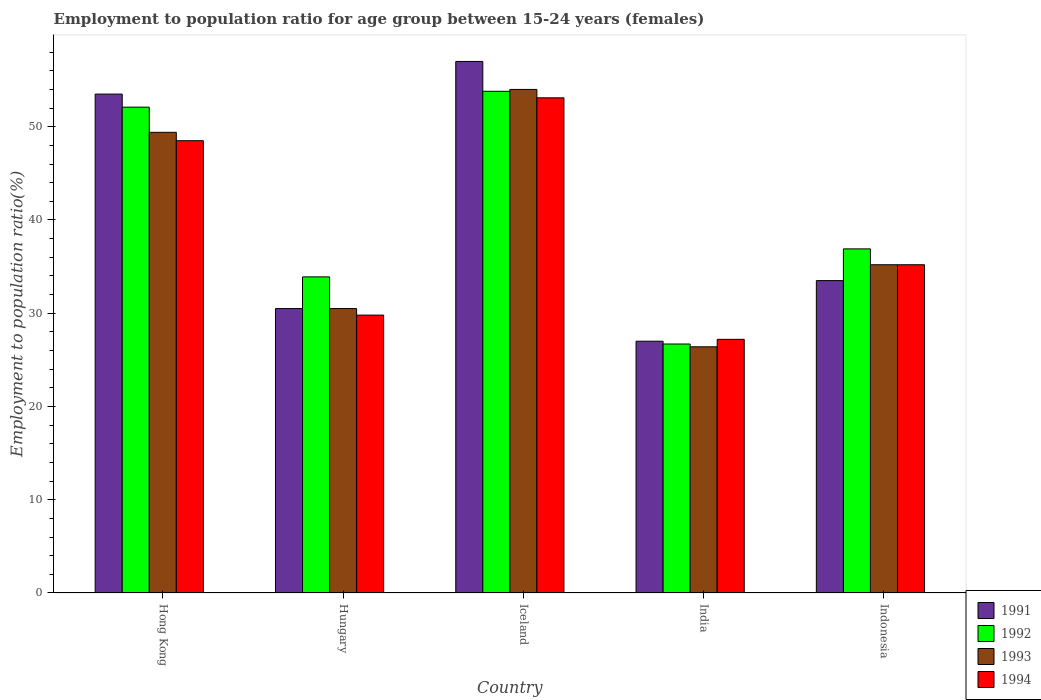Are the number of bars per tick equal to the number of legend labels?
Your answer should be very brief. Yes. How many bars are there on the 3rd tick from the left?
Offer a terse response. 4. How many bars are there on the 1st tick from the right?
Offer a terse response. 4. What is the label of the 2nd group of bars from the left?
Make the answer very short. Hungary. In how many cases, is the number of bars for a given country not equal to the number of legend labels?
Give a very brief answer. 0. What is the employment to population ratio in 1994 in Hong Kong?
Give a very brief answer. 48.5. Across all countries, what is the maximum employment to population ratio in 1992?
Ensure brevity in your answer.  53.8. Across all countries, what is the minimum employment to population ratio in 1994?
Your answer should be very brief. 27.2. What is the total employment to population ratio in 1992 in the graph?
Offer a very short reply. 203.4. What is the difference between the employment to population ratio in 1992 in Hong Kong and that in Hungary?
Provide a succinct answer. 18.2. What is the difference between the employment to population ratio in 1992 in Indonesia and the employment to population ratio in 1991 in Iceland?
Make the answer very short. -20.1. What is the average employment to population ratio in 1992 per country?
Ensure brevity in your answer.  40.68. What is the difference between the employment to population ratio of/in 1994 and employment to population ratio of/in 1993 in India?
Your response must be concise. 0.8. In how many countries, is the employment to population ratio in 1993 greater than 4 %?
Provide a short and direct response. 5. What is the ratio of the employment to population ratio in 1993 in Hong Kong to that in Iceland?
Your answer should be compact. 0.91. Is the difference between the employment to population ratio in 1994 in Iceland and Indonesia greater than the difference between the employment to population ratio in 1993 in Iceland and Indonesia?
Your answer should be very brief. No. What is the difference between the highest and the second highest employment to population ratio in 1994?
Your answer should be compact. 13.3. What is the difference between the highest and the lowest employment to population ratio in 1992?
Ensure brevity in your answer.  27.1. In how many countries, is the employment to population ratio in 1992 greater than the average employment to population ratio in 1992 taken over all countries?
Your answer should be very brief. 2. What does the 2nd bar from the right in India represents?
Provide a succinct answer. 1993. How many bars are there?
Give a very brief answer. 20. What is the difference between two consecutive major ticks on the Y-axis?
Your answer should be very brief. 10. Are the values on the major ticks of Y-axis written in scientific E-notation?
Give a very brief answer. No. Does the graph contain grids?
Keep it short and to the point. No. Where does the legend appear in the graph?
Keep it short and to the point. Bottom right. What is the title of the graph?
Offer a terse response. Employment to population ratio for age group between 15-24 years (females). What is the label or title of the X-axis?
Your answer should be very brief. Country. What is the Employment to population ratio(%) in 1991 in Hong Kong?
Offer a very short reply. 53.5. What is the Employment to population ratio(%) of 1992 in Hong Kong?
Your answer should be compact. 52.1. What is the Employment to population ratio(%) in 1993 in Hong Kong?
Your answer should be very brief. 49.4. What is the Employment to population ratio(%) in 1994 in Hong Kong?
Your response must be concise. 48.5. What is the Employment to population ratio(%) in 1991 in Hungary?
Ensure brevity in your answer.  30.5. What is the Employment to population ratio(%) of 1992 in Hungary?
Provide a short and direct response. 33.9. What is the Employment to population ratio(%) in 1993 in Hungary?
Offer a very short reply. 30.5. What is the Employment to population ratio(%) of 1994 in Hungary?
Make the answer very short. 29.8. What is the Employment to population ratio(%) in 1991 in Iceland?
Give a very brief answer. 57. What is the Employment to population ratio(%) in 1992 in Iceland?
Provide a succinct answer. 53.8. What is the Employment to population ratio(%) in 1994 in Iceland?
Provide a short and direct response. 53.1. What is the Employment to population ratio(%) of 1991 in India?
Give a very brief answer. 27. What is the Employment to population ratio(%) in 1992 in India?
Keep it short and to the point. 26.7. What is the Employment to population ratio(%) of 1993 in India?
Make the answer very short. 26.4. What is the Employment to population ratio(%) in 1994 in India?
Offer a very short reply. 27.2. What is the Employment to population ratio(%) of 1991 in Indonesia?
Offer a very short reply. 33.5. What is the Employment to population ratio(%) of 1992 in Indonesia?
Keep it short and to the point. 36.9. What is the Employment to population ratio(%) in 1993 in Indonesia?
Your answer should be very brief. 35.2. What is the Employment to population ratio(%) of 1994 in Indonesia?
Make the answer very short. 35.2. Across all countries, what is the maximum Employment to population ratio(%) of 1991?
Make the answer very short. 57. Across all countries, what is the maximum Employment to population ratio(%) of 1992?
Offer a very short reply. 53.8. Across all countries, what is the maximum Employment to population ratio(%) of 1994?
Offer a very short reply. 53.1. Across all countries, what is the minimum Employment to population ratio(%) of 1991?
Ensure brevity in your answer.  27. Across all countries, what is the minimum Employment to population ratio(%) of 1992?
Give a very brief answer. 26.7. Across all countries, what is the minimum Employment to population ratio(%) of 1993?
Provide a succinct answer. 26.4. Across all countries, what is the minimum Employment to population ratio(%) in 1994?
Give a very brief answer. 27.2. What is the total Employment to population ratio(%) of 1991 in the graph?
Your answer should be very brief. 201.5. What is the total Employment to population ratio(%) in 1992 in the graph?
Offer a very short reply. 203.4. What is the total Employment to population ratio(%) in 1993 in the graph?
Your response must be concise. 195.5. What is the total Employment to population ratio(%) of 1994 in the graph?
Your answer should be compact. 193.8. What is the difference between the Employment to population ratio(%) in 1991 in Hong Kong and that in Hungary?
Your response must be concise. 23. What is the difference between the Employment to population ratio(%) of 1992 in Hong Kong and that in Hungary?
Your answer should be compact. 18.2. What is the difference between the Employment to population ratio(%) of 1993 in Hong Kong and that in Hungary?
Offer a terse response. 18.9. What is the difference between the Employment to population ratio(%) in 1992 in Hong Kong and that in India?
Give a very brief answer. 25.4. What is the difference between the Employment to population ratio(%) of 1994 in Hong Kong and that in India?
Your response must be concise. 21.3. What is the difference between the Employment to population ratio(%) of 1991 in Hong Kong and that in Indonesia?
Keep it short and to the point. 20. What is the difference between the Employment to population ratio(%) in 1993 in Hong Kong and that in Indonesia?
Provide a short and direct response. 14.2. What is the difference between the Employment to population ratio(%) of 1994 in Hong Kong and that in Indonesia?
Provide a short and direct response. 13.3. What is the difference between the Employment to population ratio(%) of 1991 in Hungary and that in Iceland?
Provide a short and direct response. -26.5. What is the difference between the Employment to population ratio(%) in 1992 in Hungary and that in Iceland?
Offer a very short reply. -19.9. What is the difference between the Employment to population ratio(%) of 1993 in Hungary and that in Iceland?
Your answer should be compact. -23.5. What is the difference between the Employment to population ratio(%) in 1994 in Hungary and that in Iceland?
Provide a short and direct response. -23.3. What is the difference between the Employment to population ratio(%) of 1992 in Hungary and that in India?
Make the answer very short. 7.2. What is the difference between the Employment to population ratio(%) in 1992 in Iceland and that in India?
Provide a short and direct response. 27.1. What is the difference between the Employment to population ratio(%) in 1993 in Iceland and that in India?
Keep it short and to the point. 27.6. What is the difference between the Employment to population ratio(%) in 1994 in Iceland and that in India?
Give a very brief answer. 25.9. What is the difference between the Employment to population ratio(%) in 1991 in Iceland and that in Indonesia?
Offer a very short reply. 23.5. What is the difference between the Employment to population ratio(%) of 1993 in Iceland and that in Indonesia?
Offer a very short reply. 18.8. What is the difference between the Employment to population ratio(%) in 1994 in Iceland and that in Indonesia?
Offer a terse response. 17.9. What is the difference between the Employment to population ratio(%) in 1991 in India and that in Indonesia?
Ensure brevity in your answer.  -6.5. What is the difference between the Employment to population ratio(%) of 1992 in India and that in Indonesia?
Offer a terse response. -10.2. What is the difference between the Employment to population ratio(%) of 1994 in India and that in Indonesia?
Keep it short and to the point. -8. What is the difference between the Employment to population ratio(%) of 1991 in Hong Kong and the Employment to population ratio(%) of 1992 in Hungary?
Make the answer very short. 19.6. What is the difference between the Employment to population ratio(%) of 1991 in Hong Kong and the Employment to population ratio(%) of 1993 in Hungary?
Provide a short and direct response. 23. What is the difference between the Employment to population ratio(%) in 1991 in Hong Kong and the Employment to population ratio(%) in 1994 in Hungary?
Your answer should be very brief. 23.7. What is the difference between the Employment to population ratio(%) of 1992 in Hong Kong and the Employment to population ratio(%) of 1993 in Hungary?
Offer a very short reply. 21.6. What is the difference between the Employment to population ratio(%) of 1992 in Hong Kong and the Employment to population ratio(%) of 1994 in Hungary?
Your response must be concise. 22.3. What is the difference between the Employment to population ratio(%) in 1993 in Hong Kong and the Employment to population ratio(%) in 1994 in Hungary?
Make the answer very short. 19.6. What is the difference between the Employment to population ratio(%) of 1991 in Hong Kong and the Employment to population ratio(%) of 1992 in Iceland?
Offer a terse response. -0.3. What is the difference between the Employment to population ratio(%) in 1991 in Hong Kong and the Employment to population ratio(%) in 1993 in Iceland?
Give a very brief answer. -0.5. What is the difference between the Employment to population ratio(%) of 1992 in Hong Kong and the Employment to population ratio(%) of 1994 in Iceland?
Offer a terse response. -1. What is the difference between the Employment to population ratio(%) of 1991 in Hong Kong and the Employment to population ratio(%) of 1992 in India?
Offer a terse response. 26.8. What is the difference between the Employment to population ratio(%) in 1991 in Hong Kong and the Employment to population ratio(%) in 1993 in India?
Offer a very short reply. 27.1. What is the difference between the Employment to population ratio(%) of 1991 in Hong Kong and the Employment to population ratio(%) of 1994 in India?
Provide a short and direct response. 26.3. What is the difference between the Employment to population ratio(%) in 1992 in Hong Kong and the Employment to population ratio(%) in 1993 in India?
Keep it short and to the point. 25.7. What is the difference between the Employment to population ratio(%) in 1992 in Hong Kong and the Employment to population ratio(%) in 1994 in India?
Provide a succinct answer. 24.9. What is the difference between the Employment to population ratio(%) of 1991 in Hong Kong and the Employment to population ratio(%) of 1994 in Indonesia?
Your response must be concise. 18.3. What is the difference between the Employment to population ratio(%) of 1991 in Hungary and the Employment to population ratio(%) of 1992 in Iceland?
Offer a terse response. -23.3. What is the difference between the Employment to population ratio(%) of 1991 in Hungary and the Employment to population ratio(%) of 1993 in Iceland?
Provide a succinct answer. -23.5. What is the difference between the Employment to population ratio(%) in 1991 in Hungary and the Employment to population ratio(%) in 1994 in Iceland?
Your answer should be very brief. -22.6. What is the difference between the Employment to population ratio(%) of 1992 in Hungary and the Employment to population ratio(%) of 1993 in Iceland?
Make the answer very short. -20.1. What is the difference between the Employment to population ratio(%) in 1992 in Hungary and the Employment to population ratio(%) in 1994 in Iceland?
Provide a succinct answer. -19.2. What is the difference between the Employment to population ratio(%) of 1993 in Hungary and the Employment to population ratio(%) of 1994 in Iceland?
Your answer should be very brief. -22.6. What is the difference between the Employment to population ratio(%) of 1991 in Hungary and the Employment to population ratio(%) of 1992 in India?
Make the answer very short. 3.8. What is the difference between the Employment to population ratio(%) in 1992 in Hungary and the Employment to population ratio(%) in 1994 in India?
Give a very brief answer. 6.7. What is the difference between the Employment to population ratio(%) in 1992 in Hungary and the Employment to population ratio(%) in 1994 in Indonesia?
Make the answer very short. -1.3. What is the difference between the Employment to population ratio(%) in 1991 in Iceland and the Employment to population ratio(%) in 1992 in India?
Provide a short and direct response. 30.3. What is the difference between the Employment to population ratio(%) of 1991 in Iceland and the Employment to population ratio(%) of 1993 in India?
Your answer should be compact. 30.6. What is the difference between the Employment to population ratio(%) in 1991 in Iceland and the Employment to population ratio(%) in 1994 in India?
Provide a short and direct response. 29.8. What is the difference between the Employment to population ratio(%) of 1992 in Iceland and the Employment to population ratio(%) of 1993 in India?
Provide a succinct answer. 27.4. What is the difference between the Employment to population ratio(%) in 1992 in Iceland and the Employment to population ratio(%) in 1994 in India?
Ensure brevity in your answer.  26.6. What is the difference between the Employment to population ratio(%) of 1993 in Iceland and the Employment to population ratio(%) of 1994 in India?
Offer a terse response. 26.8. What is the difference between the Employment to population ratio(%) in 1991 in Iceland and the Employment to population ratio(%) in 1992 in Indonesia?
Offer a very short reply. 20.1. What is the difference between the Employment to population ratio(%) in 1991 in Iceland and the Employment to population ratio(%) in 1993 in Indonesia?
Provide a succinct answer. 21.8. What is the difference between the Employment to population ratio(%) of 1991 in Iceland and the Employment to population ratio(%) of 1994 in Indonesia?
Give a very brief answer. 21.8. What is the difference between the Employment to population ratio(%) in 1992 in Iceland and the Employment to population ratio(%) in 1993 in Indonesia?
Offer a very short reply. 18.6. What is the difference between the Employment to population ratio(%) in 1992 in Iceland and the Employment to population ratio(%) in 1994 in Indonesia?
Offer a very short reply. 18.6. What is the difference between the Employment to population ratio(%) in 1993 in Iceland and the Employment to population ratio(%) in 1994 in Indonesia?
Provide a short and direct response. 18.8. What is the difference between the Employment to population ratio(%) of 1991 in India and the Employment to population ratio(%) of 1993 in Indonesia?
Give a very brief answer. -8.2. What is the average Employment to population ratio(%) of 1991 per country?
Your answer should be very brief. 40.3. What is the average Employment to population ratio(%) of 1992 per country?
Your answer should be very brief. 40.68. What is the average Employment to population ratio(%) of 1993 per country?
Give a very brief answer. 39.1. What is the average Employment to population ratio(%) in 1994 per country?
Provide a succinct answer. 38.76. What is the difference between the Employment to population ratio(%) of 1991 and Employment to population ratio(%) of 1992 in Hong Kong?
Your response must be concise. 1.4. What is the difference between the Employment to population ratio(%) of 1991 and Employment to population ratio(%) of 1993 in Hong Kong?
Make the answer very short. 4.1. What is the difference between the Employment to population ratio(%) in 1992 and Employment to population ratio(%) in 1993 in Hong Kong?
Make the answer very short. 2.7. What is the difference between the Employment to population ratio(%) in 1991 and Employment to population ratio(%) in 1992 in Hungary?
Keep it short and to the point. -3.4. What is the difference between the Employment to population ratio(%) in 1991 and Employment to population ratio(%) in 1994 in Hungary?
Your response must be concise. 0.7. What is the difference between the Employment to population ratio(%) in 1992 and Employment to population ratio(%) in 1993 in Hungary?
Offer a very short reply. 3.4. What is the difference between the Employment to population ratio(%) of 1992 and Employment to population ratio(%) of 1994 in Hungary?
Provide a short and direct response. 4.1. What is the difference between the Employment to population ratio(%) of 1991 and Employment to population ratio(%) of 1994 in Iceland?
Ensure brevity in your answer.  3.9. What is the difference between the Employment to population ratio(%) of 1992 and Employment to population ratio(%) of 1994 in Iceland?
Provide a short and direct response. 0.7. What is the difference between the Employment to population ratio(%) of 1993 and Employment to population ratio(%) of 1994 in Iceland?
Ensure brevity in your answer.  0.9. What is the difference between the Employment to population ratio(%) in 1991 and Employment to population ratio(%) in 1992 in India?
Ensure brevity in your answer.  0.3. What is the difference between the Employment to population ratio(%) in 1992 and Employment to population ratio(%) in 1993 in India?
Make the answer very short. 0.3. What is the difference between the Employment to population ratio(%) of 1991 and Employment to population ratio(%) of 1993 in Indonesia?
Give a very brief answer. -1.7. What is the difference between the Employment to population ratio(%) in 1992 and Employment to population ratio(%) in 1994 in Indonesia?
Offer a very short reply. 1.7. What is the ratio of the Employment to population ratio(%) in 1991 in Hong Kong to that in Hungary?
Your answer should be very brief. 1.75. What is the ratio of the Employment to population ratio(%) of 1992 in Hong Kong to that in Hungary?
Your answer should be very brief. 1.54. What is the ratio of the Employment to population ratio(%) of 1993 in Hong Kong to that in Hungary?
Give a very brief answer. 1.62. What is the ratio of the Employment to population ratio(%) in 1994 in Hong Kong to that in Hungary?
Offer a terse response. 1.63. What is the ratio of the Employment to population ratio(%) in 1991 in Hong Kong to that in Iceland?
Give a very brief answer. 0.94. What is the ratio of the Employment to population ratio(%) in 1992 in Hong Kong to that in Iceland?
Give a very brief answer. 0.97. What is the ratio of the Employment to population ratio(%) of 1993 in Hong Kong to that in Iceland?
Provide a succinct answer. 0.91. What is the ratio of the Employment to population ratio(%) of 1994 in Hong Kong to that in Iceland?
Your answer should be very brief. 0.91. What is the ratio of the Employment to population ratio(%) in 1991 in Hong Kong to that in India?
Provide a short and direct response. 1.98. What is the ratio of the Employment to population ratio(%) in 1992 in Hong Kong to that in India?
Provide a succinct answer. 1.95. What is the ratio of the Employment to population ratio(%) in 1993 in Hong Kong to that in India?
Provide a succinct answer. 1.87. What is the ratio of the Employment to population ratio(%) in 1994 in Hong Kong to that in India?
Provide a short and direct response. 1.78. What is the ratio of the Employment to population ratio(%) of 1991 in Hong Kong to that in Indonesia?
Provide a short and direct response. 1.6. What is the ratio of the Employment to population ratio(%) in 1992 in Hong Kong to that in Indonesia?
Keep it short and to the point. 1.41. What is the ratio of the Employment to population ratio(%) in 1993 in Hong Kong to that in Indonesia?
Ensure brevity in your answer.  1.4. What is the ratio of the Employment to population ratio(%) of 1994 in Hong Kong to that in Indonesia?
Your answer should be very brief. 1.38. What is the ratio of the Employment to population ratio(%) of 1991 in Hungary to that in Iceland?
Offer a terse response. 0.54. What is the ratio of the Employment to population ratio(%) of 1992 in Hungary to that in Iceland?
Provide a short and direct response. 0.63. What is the ratio of the Employment to population ratio(%) in 1993 in Hungary to that in Iceland?
Your response must be concise. 0.56. What is the ratio of the Employment to population ratio(%) in 1994 in Hungary to that in Iceland?
Give a very brief answer. 0.56. What is the ratio of the Employment to population ratio(%) of 1991 in Hungary to that in India?
Offer a terse response. 1.13. What is the ratio of the Employment to population ratio(%) in 1992 in Hungary to that in India?
Offer a very short reply. 1.27. What is the ratio of the Employment to population ratio(%) in 1993 in Hungary to that in India?
Keep it short and to the point. 1.16. What is the ratio of the Employment to population ratio(%) of 1994 in Hungary to that in India?
Give a very brief answer. 1.1. What is the ratio of the Employment to population ratio(%) in 1991 in Hungary to that in Indonesia?
Keep it short and to the point. 0.91. What is the ratio of the Employment to population ratio(%) of 1992 in Hungary to that in Indonesia?
Ensure brevity in your answer.  0.92. What is the ratio of the Employment to population ratio(%) in 1993 in Hungary to that in Indonesia?
Your answer should be very brief. 0.87. What is the ratio of the Employment to population ratio(%) in 1994 in Hungary to that in Indonesia?
Your answer should be compact. 0.85. What is the ratio of the Employment to population ratio(%) in 1991 in Iceland to that in India?
Ensure brevity in your answer.  2.11. What is the ratio of the Employment to population ratio(%) of 1992 in Iceland to that in India?
Keep it short and to the point. 2.02. What is the ratio of the Employment to population ratio(%) in 1993 in Iceland to that in India?
Ensure brevity in your answer.  2.05. What is the ratio of the Employment to population ratio(%) in 1994 in Iceland to that in India?
Your answer should be very brief. 1.95. What is the ratio of the Employment to population ratio(%) of 1991 in Iceland to that in Indonesia?
Your response must be concise. 1.7. What is the ratio of the Employment to population ratio(%) in 1992 in Iceland to that in Indonesia?
Ensure brevity in your answer.  1.46. What is the ratio of the Employment to population ratio(%) in 1993 in Iceland to that in Indonesia?
Your answer should be very brief. 1.53. What is the ratio of the Employment to population ratio(%) of 1994 in Iceland to that in Indonesia?
Keep it short and to the point. 1.51. What is the ratio of the Employment to population ratio(%) of 1991 in India to that in Indonesia?
Provide a succinct answer. 0.81. What is the ratio of the Employment to population ratio(%) of 1992 in India to that in Indonesia?
Ensure brevity in your answer.  0.72. What is the ratio of the Employment to population ratio(%) of 1993 in India to that in Indonesia?
Make the answer very short. 0.75. What is the ratio of the Employment to population ratio(%) of 1994 in India to that in Indonesia?
Make the answer very short. 0.77. What is the difference between the highest and the second highest Employment to population ratio(%) of 1991?
Give a very brief answer. 3.5. What is the difference between the highest and the second highest Employment to population ratio(%) of 1993?
Keep it short and to the point. 4.6. What is the difference between the highest and the second highest Employment to population ratio(%) of 1994?
Your answer should be compact. 4.6. What is the difference between the highest and the lowest Employment to population ratio(%) of 1991?
Ensure brevity in your answer.  30. What is the difference between the highest and the lowest Employment to population ratio(%) in 1992?
Offer a terse response. 27.1. What is the difference between the highest and the lowest Employment to population ratio(%) of 1993?
Give a very brief answer. 27.6. What is the difference between the highest and the lowest Employment to population ratio(%) in 1994?
Keep it short and to the point. 25.9. 